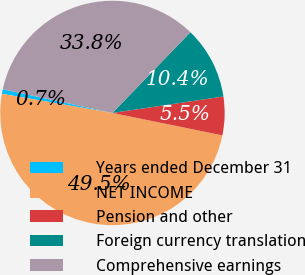Convert chart to OTSL. <chart><loc_0><loc_0><loc_500><loc_500><pie_chart><fcel>Years ended December 31<fcel>NET INCOME<fcel>Pension and other<fcel>Foreign currency translation<fcel>Comprehensive earnings<nl><fcel>0.66%<fcel>49.53%<fcel>5.54%<fcel>10.43%<fcel>33.84%<nl></chart> 